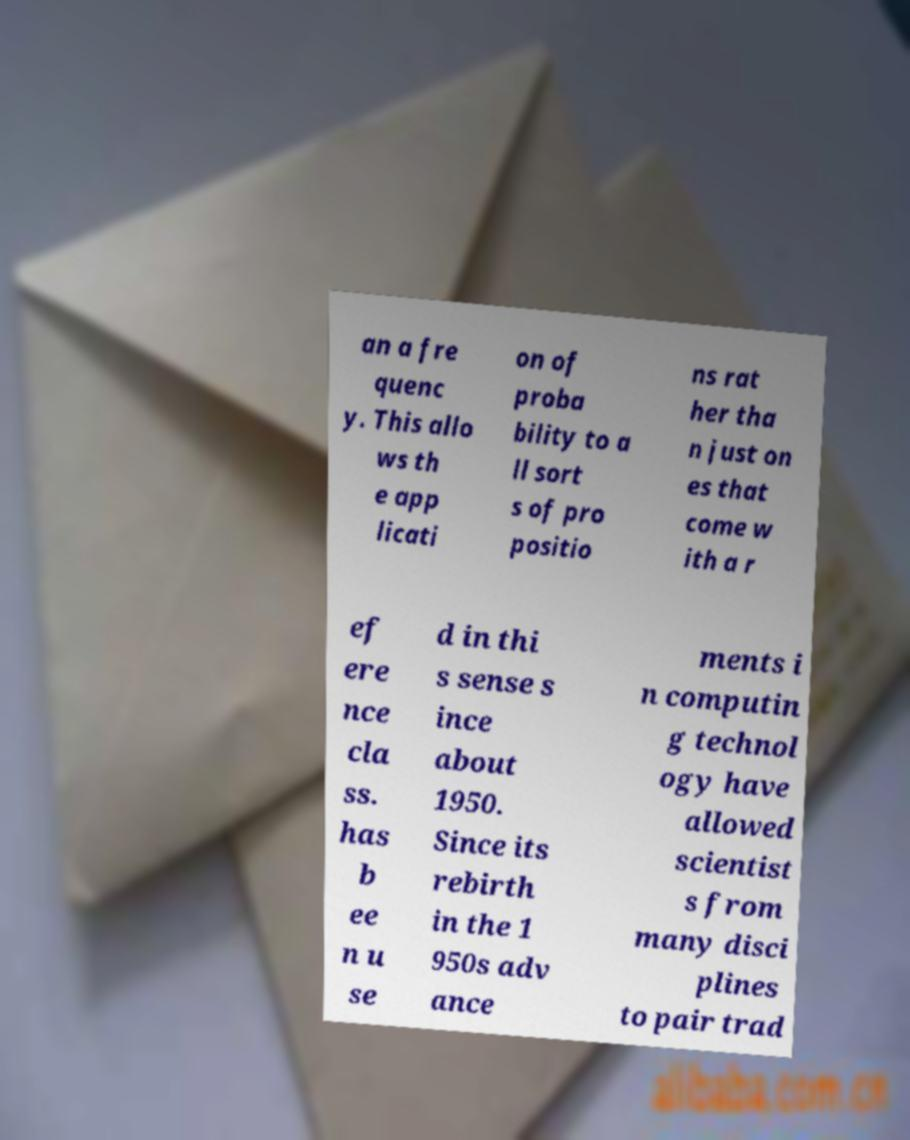What messages or text are displayed in this image? I need them in a readable, typed format. an a fre quenc y. This allo ws th e app licati on of proba bility to a ll sort s of pro positio ns rat her tha n just on es that come w ith a r ef ere nce cla ss. has b ee n u se d in thi s sense s ince about 1950. Since its rebirth in the 1 950s adv ance ments i n computin g technol ogy have allowed scientist s from many disci plines to pair trad 